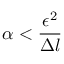<formula> <loc_0><loc_0><loc_500><loc_500>\alpha < \frac { \epsilon ^ { 2 } } { \Delta l }</formula> 